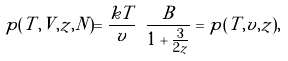<formula> <loc_0><loc_0><loc_500><loc_500>p ( T , V , z , N ) = \frac { k T } { v } \ \frac { B } { 1 + \frac { 3 } { 2 \tilde { z } } } = p ( T , v , \tilde { z } ) ,</formula> 